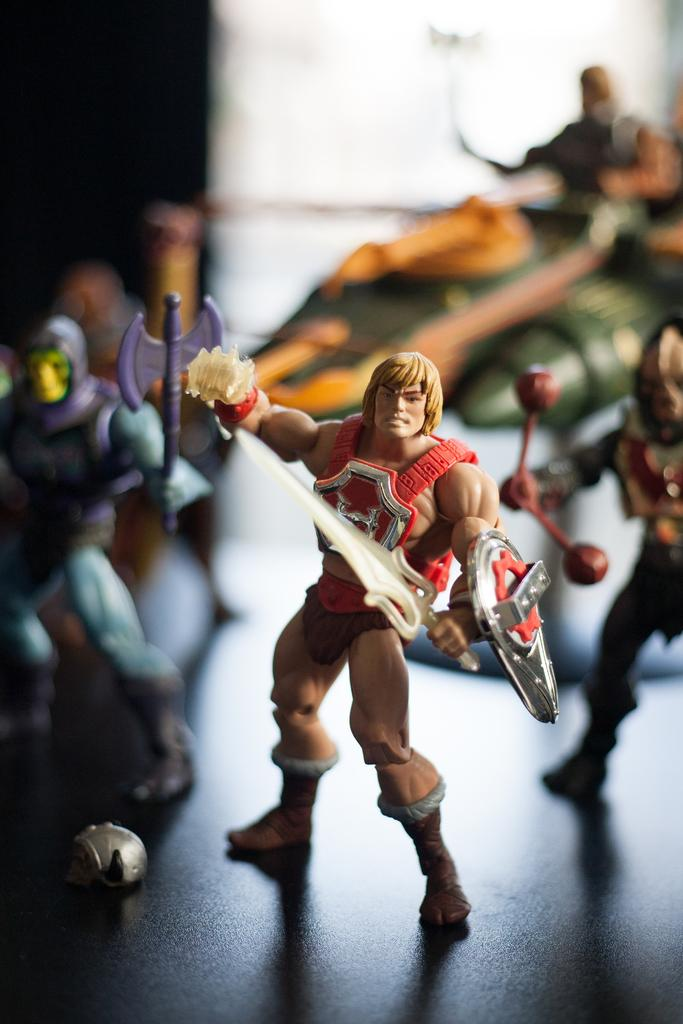What objects are present in the image? There are toys in the image. What are the toys doing in the image? The toys are holding weapons and standing on the floor. Can you describe the background of the image? The background of the image is blurry. What type of whistle can be heard in the image? There is no whistle present in the image, and therefore no sound can be heard. 